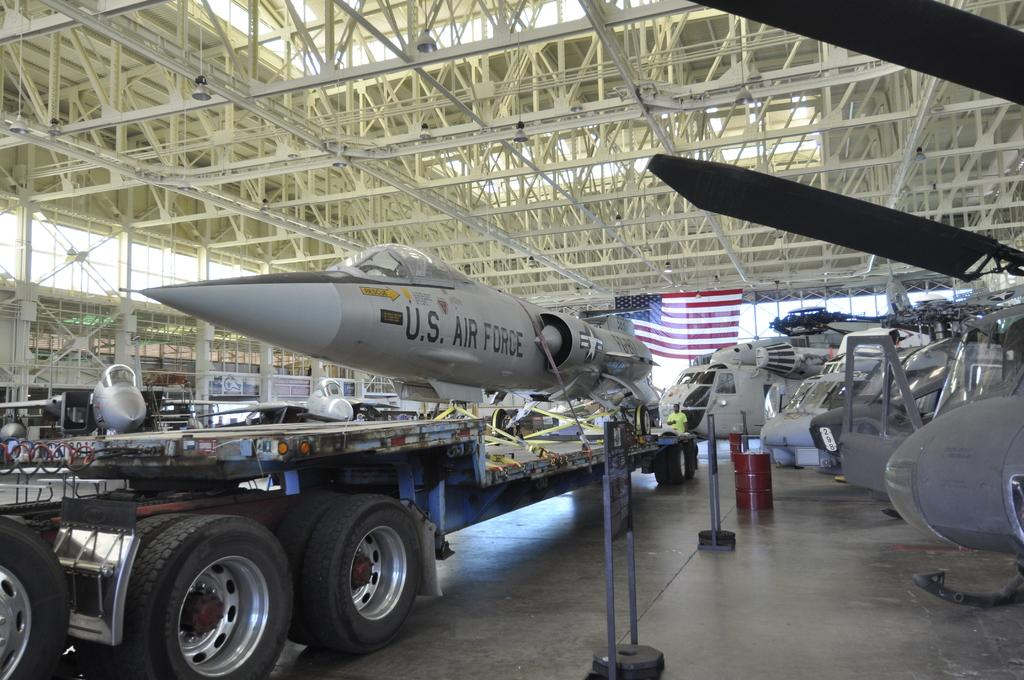<image>
Present a compact description of the photo's key features. U.S. Air Force jet being transported by another vehicle. 